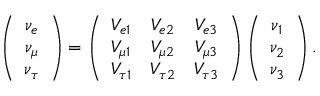<formula> <loc_0><loc_0><loc_500><loc_500>\left ( \begin{array} { c } { { \nu _ { e } } } \\ { { \nu _ { \mu } } } \\ { { \nu _ { \tau } } } \end{array} \right ) = \left ( \begin{array} { c c c } { { V _ { e 1 } } } & { { V _ { e 2 } } } & { { V _ { e 3 } } } \\ { { V _ { \mu 1 } } } & { { V _ { \mu 2 } } } & { { V _ { \mu 3 } } } \\ { { V _ { \tau 1 } } } & { { V _ { \tau 2 } } } & { { V _ { \tau 3 } } } \end{array} \right ) \left ( \begin{array} { c } { { \nu _ { 1 } } } \\ { { \nu _ { 2 } } } \\ { { \nu _ { 3 } } } \end{array} \right ) .</formula> 